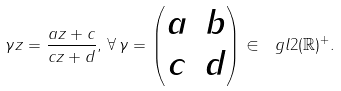Convert formula to latex. <formula><loc_0><loc_0><loc_500><loc_500>\gamma z = \frac { a z + c } { c z + d } , \, \forall \, \gamma = \begin{pmatrix} a & b \\ c & d \end{pmatrix} \in \ g l 2 ( \mathbb { R } ) ^ { + } .</formula> 